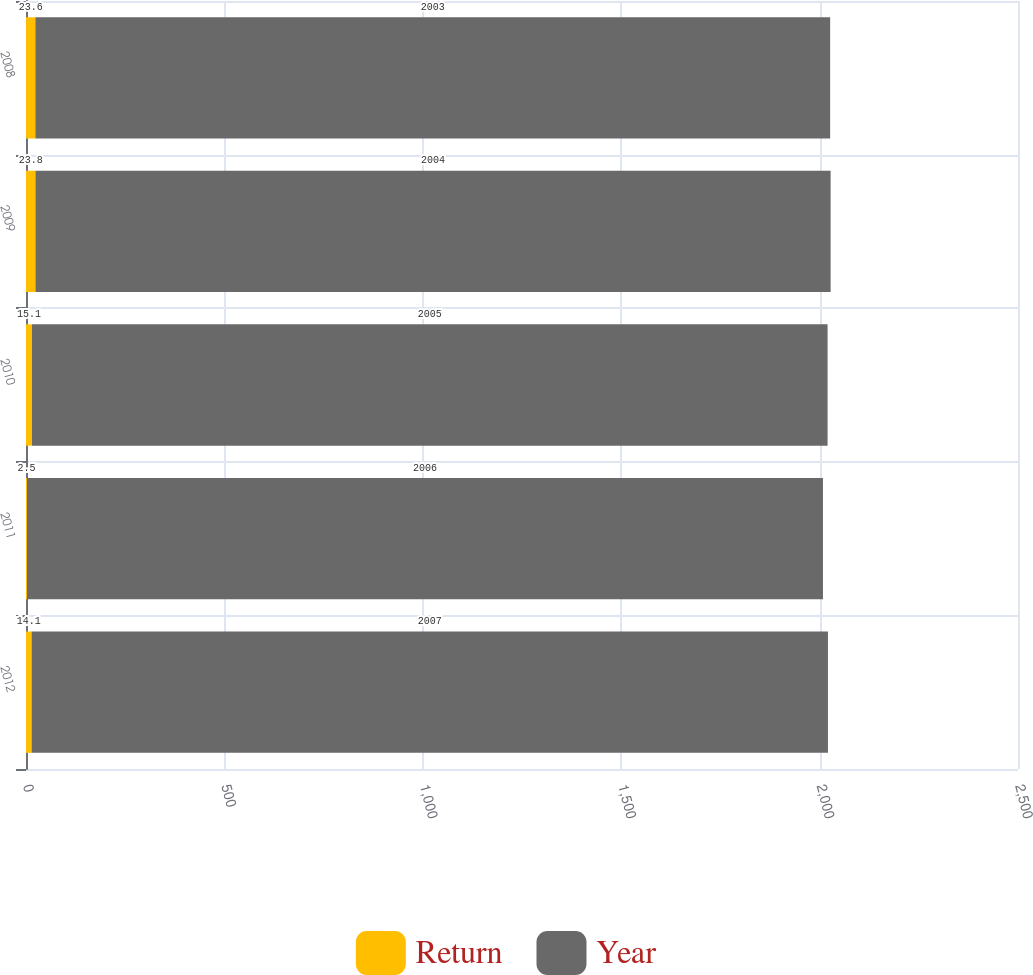Convert chart. <chart><loc_0><loc_0><loc_500><loc_500><stacked_bar_chart><ecel><fcel>2012<fcel>2011<fcel>2010<fcel>2009<fcel>2008<nl><fcel>Return<fcel>14.1<fcel>2.5<fcel>15.1<fcel>23.8<fcel>23.6<nl><fcel>Year<fcel>2007<fcel>2006<fcel>2005<fcel>2004<fcel>2003<nl></chart> 